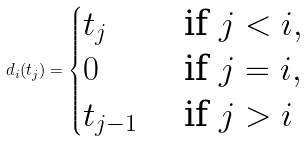Convert formula to latex. <formula><loc_0><loc_0><loc_500><loc_500>d _ { i } ( t _ { j } ) = \begin{cases} t _ { j } & \text { if } j < i , \\ 0 & \text { if } j = i , \\ t _ { j - 1 } & \text { if } j > i \end{cases}</formula> 